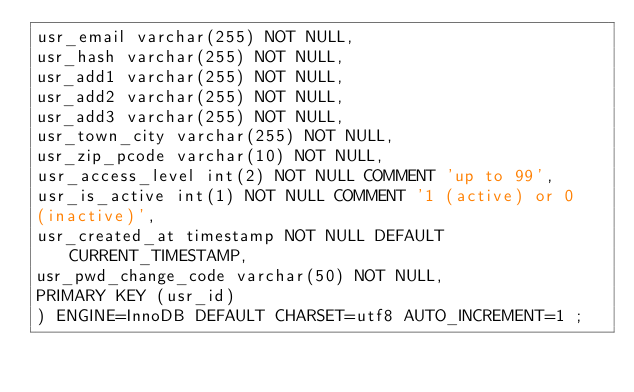Convert code to text. <code><loc_0><loc_0><loc_500><loc_500><_SQL_>usr_email varchar(255) NOT NULL,
usr_hash varchar(255) NOT NULL,
usr_add1 varchar(255) NOT NULL,
usr_add2 varchar(255) NOT NULL,
usr_add3 varchar(255) NOT NULL,
usr_town_city varchar(255) NOT NULL,
usr_zip_pcode varchar(10) NOT NULL,
usr_access_level int(2) NOT NULL COMMENT 'up to 99',
usr_is_active int(1) NOT NULL COMMENT '1 (active) or 0
(inactive)',
usr_created_at timestamp NOT NULL DEFAULT CURRENT_TIMESTAMP,
usr_pwd_change_code varchar(50) NOT NULL,
PRIMARY KEY (usr_id)
) ENGINE=InnoDB DEFAULT CHARSET=utf8 AUTO_INCREMENT=1 ;
</code> 